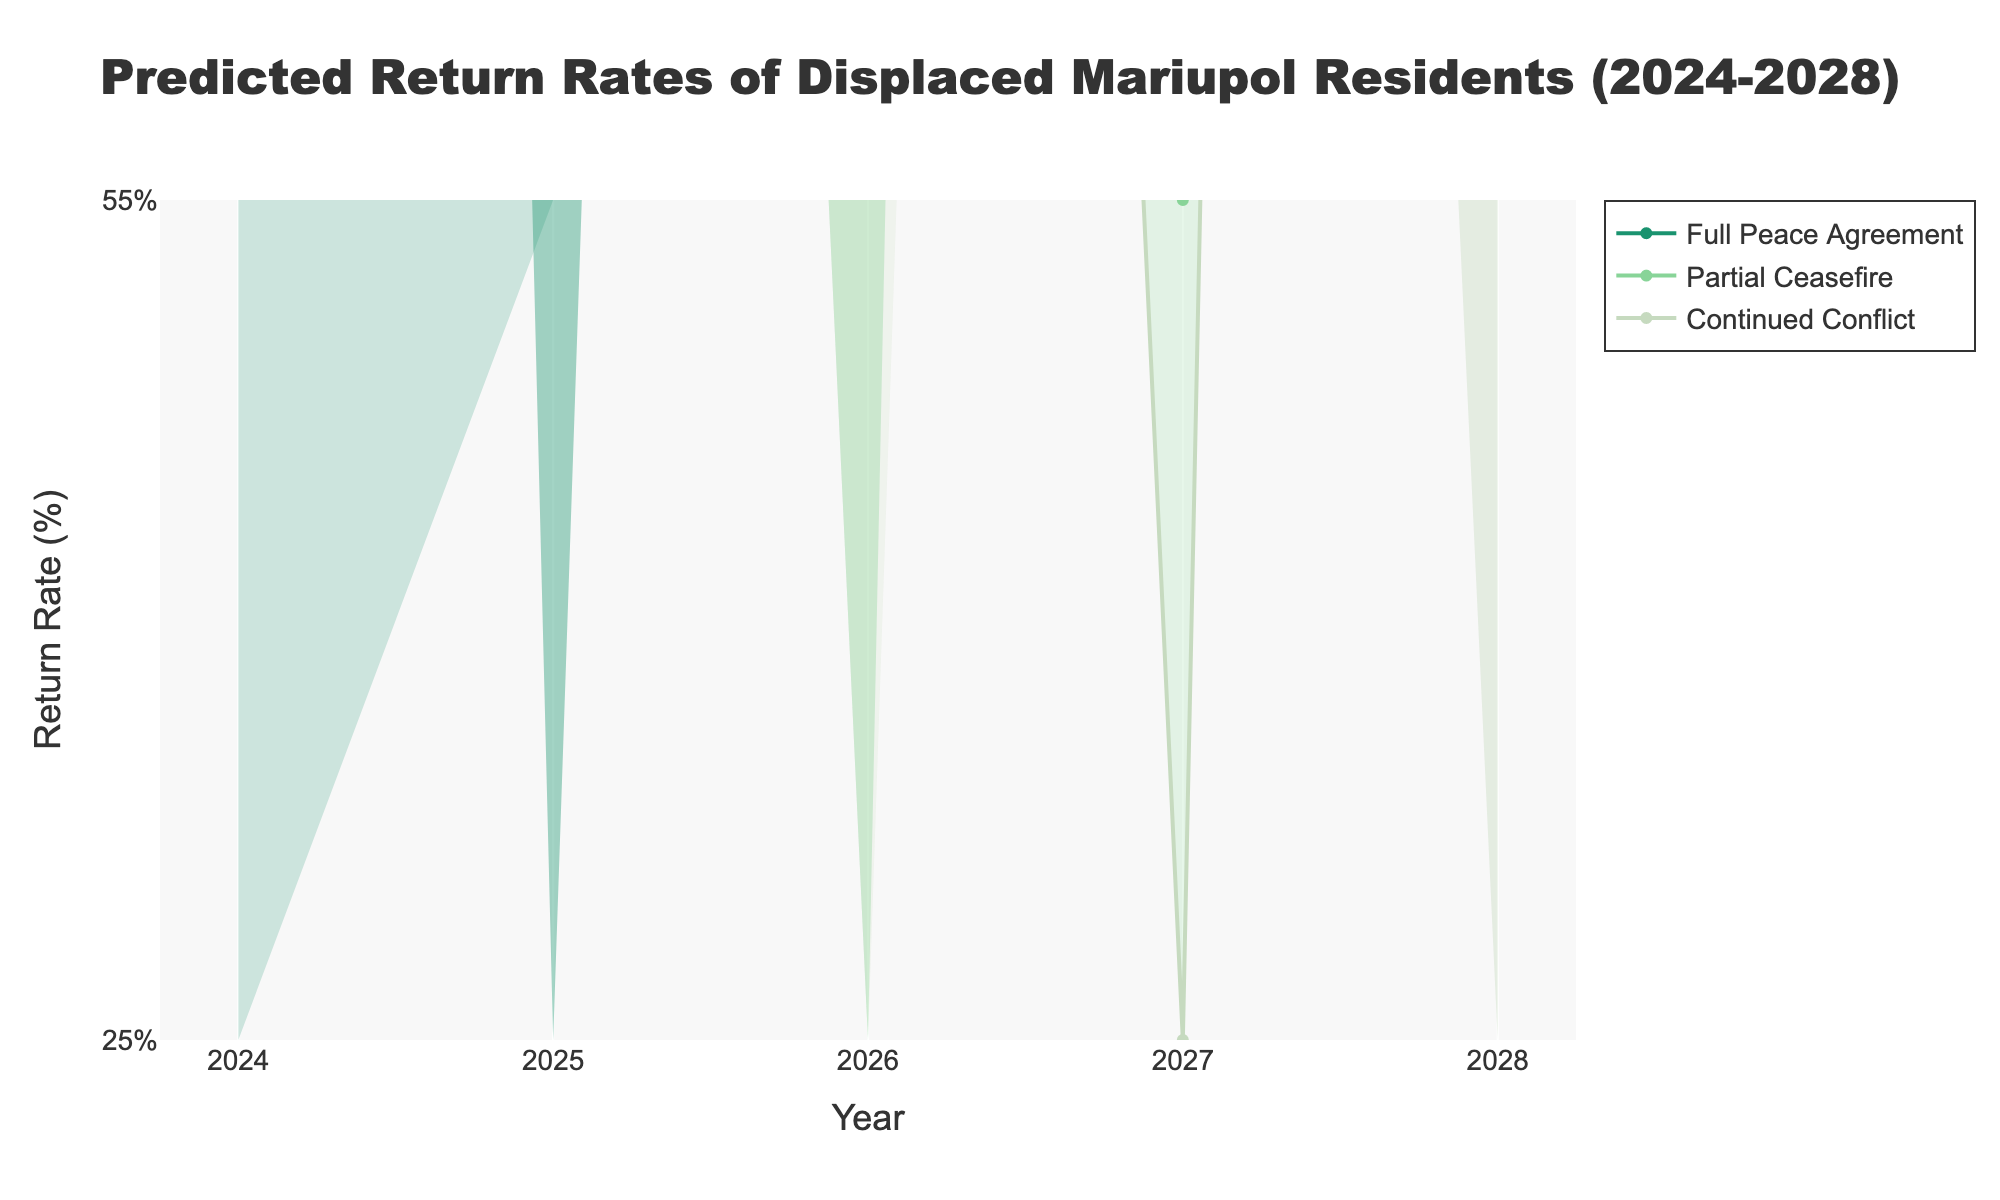what is the title of the figure? The title of the figure can be found at the top and it states what the chart is about.
Answer: Predicted Return Rates of Displaced Mariupol Residents (2024-2028) How many scenarios are compared in the figure? Count the different scenarios represented by different colors and lines in the figure.
Answer: 3 What does the y-axis represent? Look at the label on the y-axis to determine what it measures.
Answer: Return Rate (%) Which scenario shows the highest median return rate in 2028? Observe the median lines and identify which scenario has the highest value for the year 2028.
Answer: Full Peace Agreement In 2026, what is the range between the 10th percentile and the 90th percentile for the "Continued Conflict" scenario? Find the 10th and 90th percentile values for the "Continued Conflict" scenario in 2026 and subtract the 10th percentile value from the 90th percentile value.
Answer: 22% What is the trend in the median return rate for the "Partial Ceasefire" scenario from 2024 to 2028? Observe the median line for the "Partial Ceasefire" scenario across the years 2024 to 2028 to determine if the trend increases, decreases, or remains the same.
Answer: Increases By how much does the median return rate for the "Full Peace Agreement" scenario increase from 2024 to 2025? Compare the median values for the "Full Peace Agreement" scenario in 2024 and 2025 and find the difference.
Answer: 20% Which year shows the smallest difference in the 25th to 75th percentile range for the "Continued Conflict" scenario? Compare the range widths (difference between 75th and 25th percentile) for the "Continued Conflict" scenario across all years to find the smallest difference.
Answer: 2024 What scenario in 2025 shows the largest uncertainty range (10th to 90th percentile)? Compare the widths (difference between 90th and 10th percentile) among all scenarios in the year 2025 to identify the largest.
Answer: Full Peace Agreement In 2027, how much higher is the upper bound (90th percentile) for the "Partial Ceasefire" scenario compared to the "Continued Conflict" scenario? Find the 90th percentile values for both scenarios in 2027 and calculate the difference by subtracting the "Continued Conflict" value from the "Partial Ceasefire" value.
Answer: 30% 